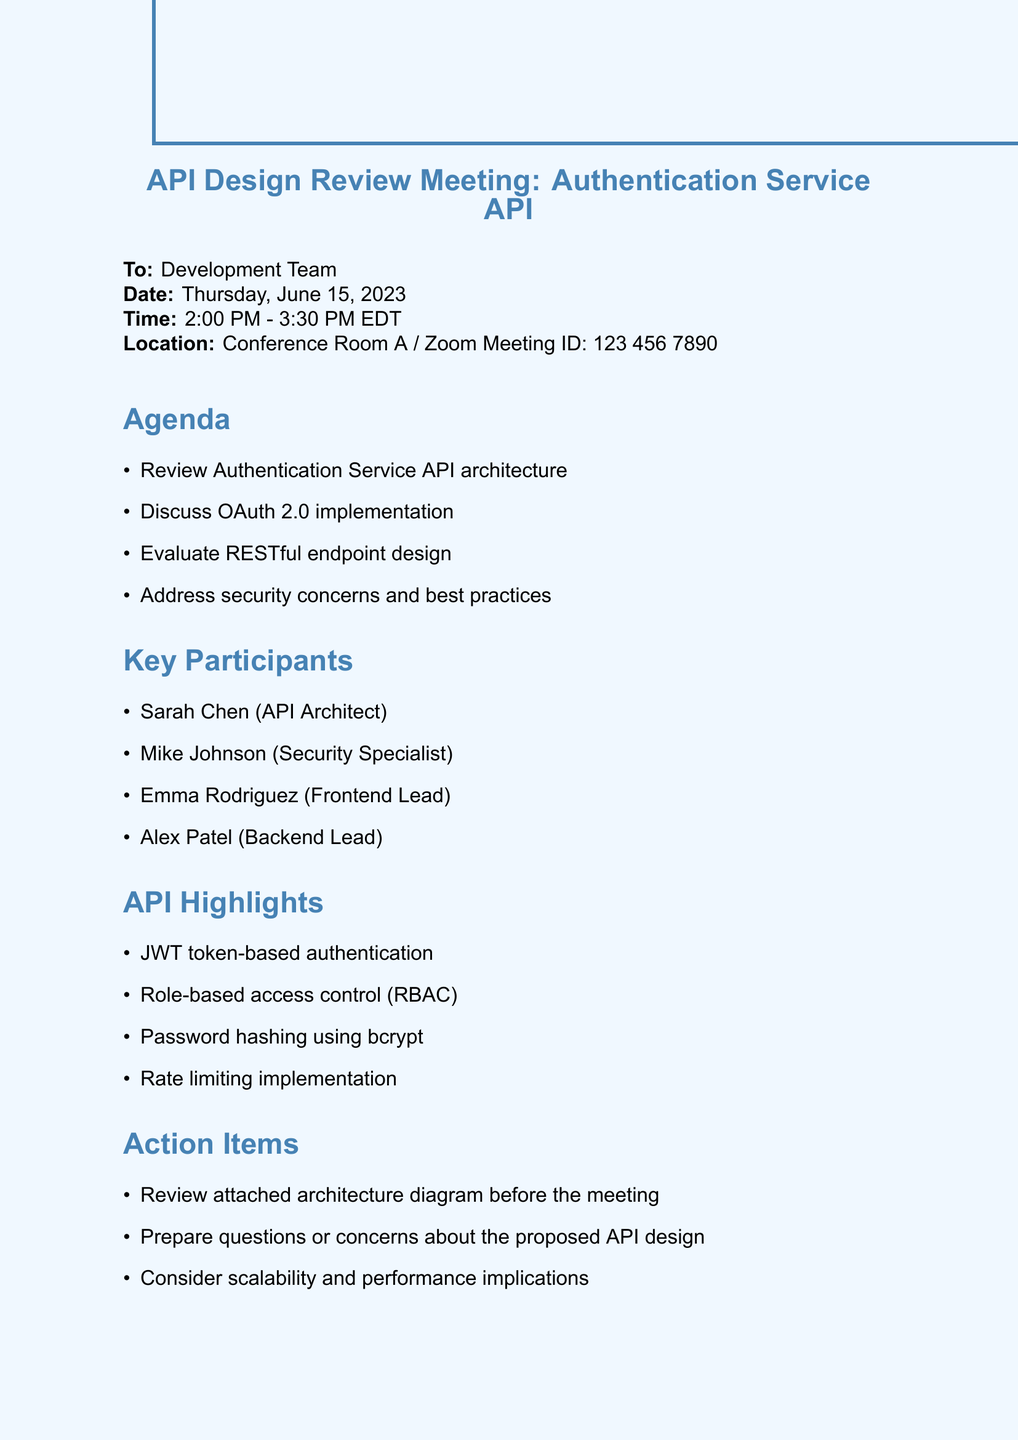what is the subject of the email? The subject of the email is provided at the top of the document, indicating the focus of the meeting.
Answer: API Design Review Meeting: Authentication Service API who is the email recipient? The recipient of the email is explicitly mentioned in the document.
Answer: Development Team what date is the meeting scheduled for? The document specifies the date of the meeting clearly.
Answer: Thursday, June 15, 2023 who is the API Architect participating in the meeting? The key participants are listed, including their roles, to identify specific individuals.
Answer: Sarah Chen what is one of the key agenda items for the meeting? The agenda section highlights specific topics that will be discussed during the meeting.
Answer: Review Authentication Service API architecture how long is the scheduled duration of the meeting? The meeting time frame gives an understanding of its length, mentioned in the timing details.
Answer: 1 hour 30 minutes what is one of the action items before the meeting? The action items specified indicate preparations required before the meeting takes place.
Answer: Review attached architecture diagram before the meeting what security mechanism is highlighted in the API? The API highlights certain features, including security aspects that are vital for implementation.
Answer: JWT token-based authentication how many key participants are listed in the document? The document contains a list of participants, which allows us to count them.
Answer: 4 